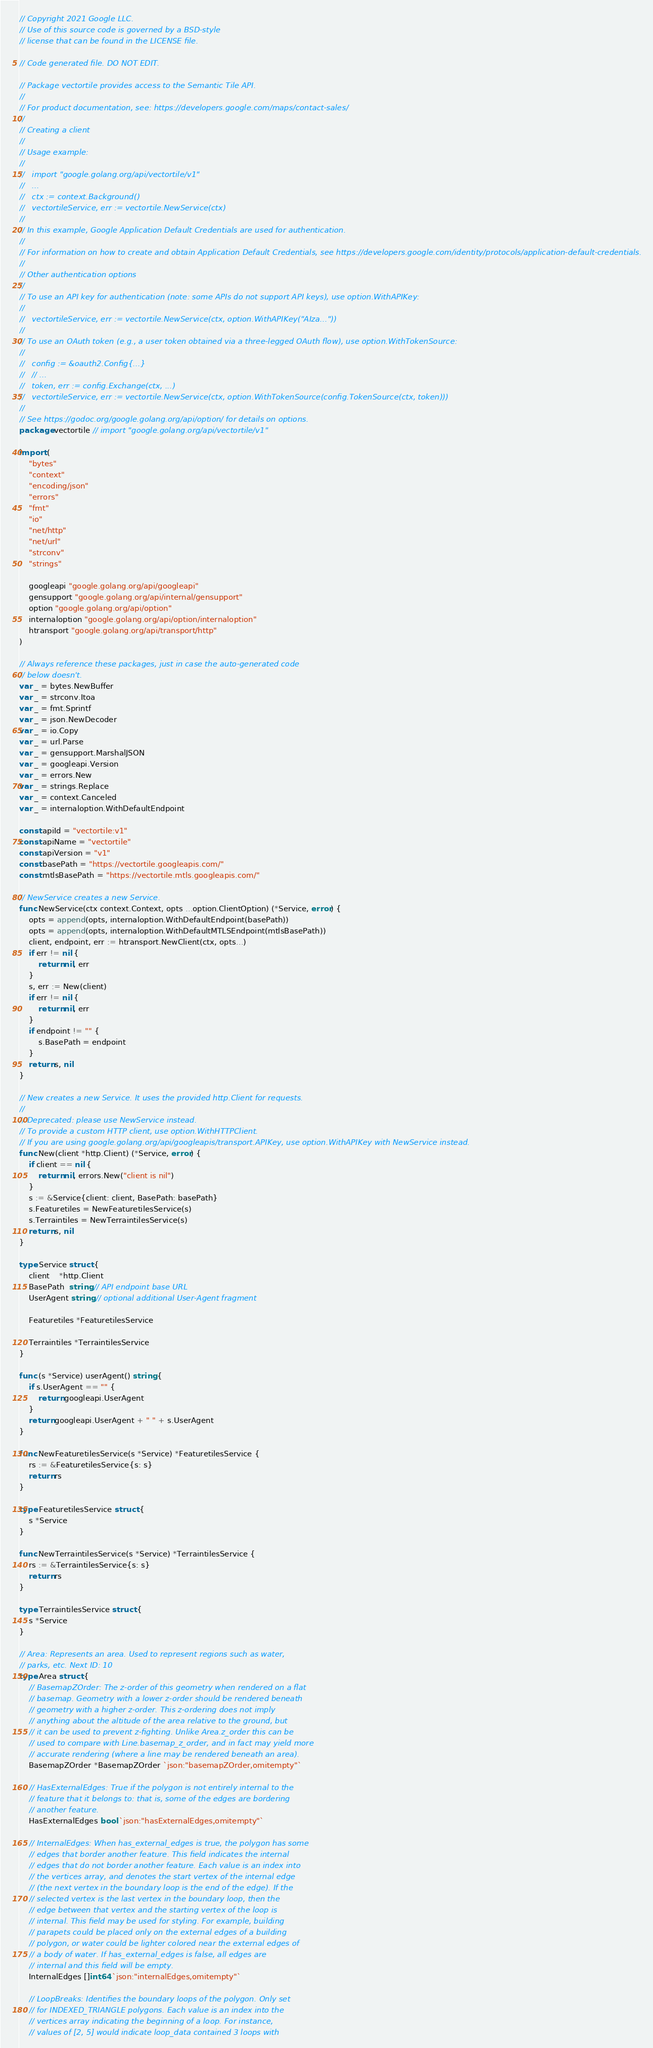<code> <loc_0><loc_0><loc_500><loc_500><_Go_>// Copyright 2021 Google LLC.
// Use of this source code is governed by a BSD-style
// license that can be found in the LICENSE file.

// Code generated file. DO NOT EDIT.

// Package vectortile provides access to the Semantic Tile API.
//
// For product documentation, see: https://developers.google.com/maps/contact-sales/
//
// Creating a client
//
// Usage example:
//
//   import "google.golang.org/api/vectortile/v1"
//   ...
//   ctx := context.Background()
//   vectortileService, err := vectortile.NewService(ctx)
//
// In this example, Google Application Default Credentials are used for authentication.
//
// For information on how to create and obtain Application Default Credentials, see https://developers.google.com/identity/protocols/application-default-credentials.
//
// Other authentication options
//
// To use an API key for authentication (note: some APIs do not support API keys), use option.WithAPIKey:
//
//   vectortileService, err := vectortile.NewService(ctx, option.WithAPIKey("AIza..."))
//
// To use an OAuth token (e.g., a user token obtained via a three-legged OAuth flow), use option.WithTokenSource:
//
//   config := &oauth2.Config{...}
//   // ...
//   token, err := config.Exchange(ctx, ...)
//   vectortileService, err := vectortile.NewService(ctx, option.WithTokenSource(config.TokenSource(ctx, token)))
//
// See https://godoc.org/google.golang.org/api/option/ for details on options.
package vectortile // import "google.golang.org/api/vectortile/v1"

import (
	"bytes"
	"context"
	"encoding/json"
	"errors"
	"fmt"
	"io"
	"net/http"
	"net/url"
	"strconv"
	"strings"

	googleapi "google.golang.org/api/googleapi"
	gensupport "google.golang.org/api/internal/gensupport"
	option "google.golang.org/api/option"
	internaloption "google.golang.org/api/option/internaloption"
	htransport "google.golang.org/api/transport/http"
)

// Always reference these packages, just in case the auto-generated code
// below doesn't.
var _ = bytes.NewBuffer
var _ = strconv.Itoa
var _ = fmt.Sprintf
var _ = json.NewDecoder
var _ = io.Copy
var _ = url.Parse
var _ = gensupport.MarshalJSON
var _ = googleapi.Version
var _ = errors.New
var _ = strings.Replace
var _ = context.Canceled
var _ = internaloption.WithDefaultEndpoint

const apiId = "vectortile:v1"
const apiName = "vectortile"
const apiVersion = "v1"
const basePath = "https://vectortile.googleapis.com/"
const mtlsBasePath = "https://vectortile.mtls.googleapis.com/"

// NewService creates a new Service.
func NewService(ctx context.Context, opts ...option.ClientOption) (*Service, error) {
	opts = append(opts, internaloption.WithDefaultEndpoint(basePath))
	opts = append(opts, internaloption.WithDefaultMTLSEndpoint(mtlsBasePath))
	client, endpoint, err := htransport.NewClient(ctx, opts...)
	if err != nil {
		return nil, err
	}
	s, err := New(client)
	if err != nil {
		return nil, err
	}
	if endpoint != "" {
		s.BasePath = endpoint
	}
	return s, nil
}

// New creates a new Service. It uses the provided http.Client for requests.
//
// Deprecated: please use NewService instead.
// To provide a custom HTTP client, use option.WithHTTPClient.
// If you are using google.golang.org/api/googleapis/transport.APIKey, use option.WithAPIKey with NewService instead.
func New(client *http.Client) (*Service, error) {
	if client == nil {
		return nil, errors.New("client is nil")
	}
	s := &Service{client: client, BasePath: basePath}
	s.Featuretiles = NewFeaturetilesService(s)
	s.Terraintiles = NewTerraintilesService(s)
	return s, nil
}

type Service struct {
	client    *http.Client
	BasePath  string // API endpoint base URL
	UserAgent string // optional additional User-Agent fragment

	Featuretiles *FeaturetilesService

	Terraintiles *TerraintilesService
}

func (s *Service) userAgent() string {
	if s.UserAgent == "" {
		return googleapi.UserAgent
	}
	return googleapi.UserAgent + " " + s.UserAgent
}

func NewFeaturetilesService(s *Service) *FeaturetilesService {
	rs := &FeaturetilesService{s: s}
	return rs
}

type FeaturetilesService struct {
	s *Service
}

func NewTerraintilesService(s *Service) *TerraintilesService {
	rs := &TerraintilesService{s: s}
	return rs
}

type TerraintilesService struct {
	s *Service
}

// Area: Represents an area. Used to represent regions such as water,
// parks, etc. Next ID: 10
type Area struct {
	// BasemapZOrder: The z-order of this geometry when rendered on a flat
	// basemap. Geometry with a lower z-order should be rendered beneath
	// geometry with a higher z-order. This z-ordering does not imply
	// anything about the altitude of the area relative to the ground, but
	// it can be used to prevent z-fighting. Unlike Area.z_order this can be
	// used to compare with Line.basemap_z_order, and in fact may yield more
	// accurate rendering (where a line may be rendered beneath an area).
	BasemapZOrder *BasemapZOrder `json:"basemapZOrder,omitempty"`

	// HasExternalEdges: True if the polygon is not entirely internal to the
	// feature that it belongs to: that is, some of the edges are bordering
	// another feature.
	HasExternalEdges bool `json:"hasExternalEdges,omitempty"`

	// InternalEdges: When has_external_edges is true, the polygon has some
	// edges that border another feature. This field indicates the internal
	// edges that do not border another feature. Each value is an index into
	// the vertices array, and denotes the start vertex of the internal edge
	// (the next vertex in the boundary loop is the end of the edge). If the
	// selected vertex is the last vertex in the boundary loop, then the
	// edge between that vertex and the starting vertex of the loop is
	// internal. This field may be used for styling. For example, building
	// parapets could be placed only on the external edges of a building
	// polygon, or water could be lighter colored near the external edges of
	// a body of water. If has_external_edges is false, all edges are
	// internal and this field will be empty.
	InternalEdges []int64 `json:"internalEdges,omitempty"`

	// LoopBreaks: Identifies the boundary loops of the polygon. Only set
	// for INDEXED_TRIANGLE polygons. Each value is an index into the
	// vertices array indicating the beginning of a loop. For instance,
	// values of [2, 5] would indicate loop_data contained 3 loops with</code> 